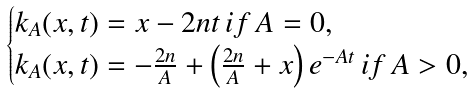Convert formula to latex. <formula><loc_0><loc_0><loc_500><loc_500>\begin{cases} k _ { A } ( x , t ) = x - 2 n t \, i f \, A = 0 , \\ k _ { A } ( x , t ) = - \frac { 2 n } { A } + \left ( \frac { 2 n } { A } + x \right ) e ^ { - A t } \, i f \, A > 0 , \end{cases}</formula> 